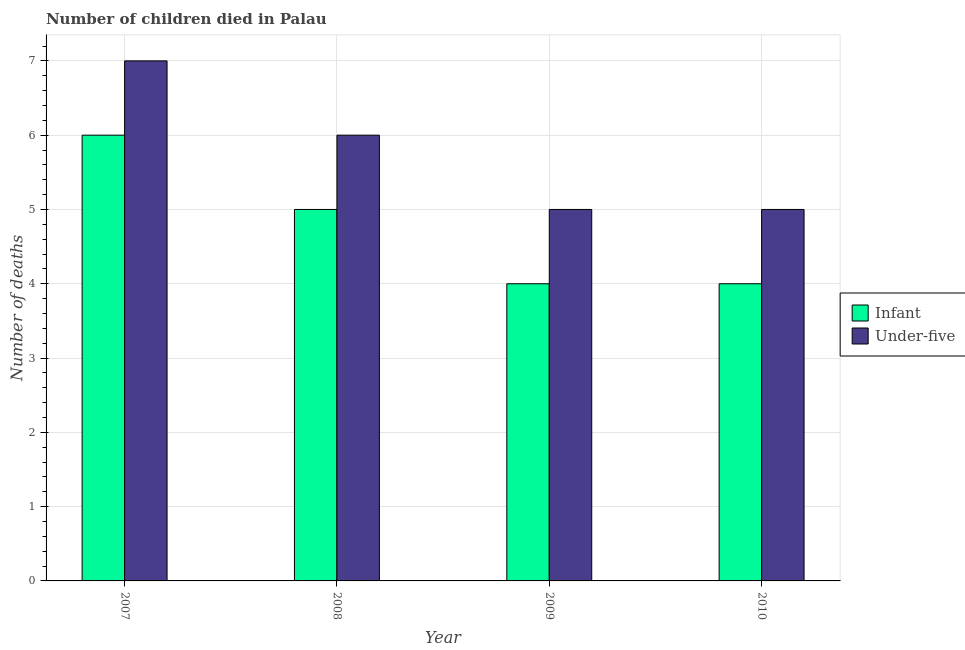How many different coloured bars are there?
Ensure brevity in your answer.  2. Are the number of bars per tick equal to the number of legend labels?
Your answer should be compact. Yes. Are the number of bars on each tick of the X-axis equal?
Ensure brevity in your answer.  Yes. How many bars are there on the 1st tick from the left?
Your answer should be very brief. 2. What is the number of under-five deaths in 2009?
Keep it short and to the point. 5. Across all years, what is the maximum number of under-five deaths?
Offer a very short reply. 7. Across all years, what is the minimum number of infant deaths?
Your answer should be compact. 4. What is the total number of infant deaths in the graph?
Offer a very short reply. 19. What is the difference between the number of infant deaths in 2007 and that in 2009?
Offer a very short reply. 2. What is the difference between the number of under-five deaths in 2009 and the number of infant deaths in 2007?
Provide a succinct answer. -2. What is the average number of under-five deaths per year?
Provide a short and direct response. 5.75. What is the ratio of the number of under-five deaths in 2008 to that in 2010?
Offer a terse response. 1.2. What is the difference between the highest and the lowest number of under-five deaths?
Your answer should be very brief. 2. Is the sum of the number of under-five deaths in 2008 and 2010 greater than the maximum number of infant deaths across all years?
Give a very brief answer. Yes. What does the 1st bar from the left in 2008 represents?
Ensure brevity in your answer.  Infant. What does the 2nd bar from the right in 2007 represents?
Give a very brief answer. Infant. How many bars are there?
Ensure brevity in your answer.  8. Are all the bars in the graph horizontal?
Offer a terse response. No. Does the graph contain grids?
Your answer should be compact. Yes. How are the legend labels stacked?
Offer a very short reply. Vertical. What is the title of the graph?
Your response must be concise. Number of children died in Palau. Does "Males" appear as one of the legend labels in the graph?
Offer a very short reply. No. What is the label or title of the X-axis?
Your answer should be compact. Year. What is the label or title of the Y-axis?
Offer a terse response. Number of deaths. What is the Number of deaths in Under-five in 2008?
Your answer should be very brief. 6. What is the Number of deaths in Infant in 2009?
Provide a short and direct response. 4. What is the Number of deaths of Under-five in 2009?
Your answer should be compact. 5. What is the Number of deaths in Infant in 2010?
Offer a terse response. 4. Across all years, what is the maximum Number of deaths in Infant?
Offer a very short reply. 6. Across all years, what is the maximum Number of deaths of Under-five?
Offer a very short reply. 7. Across all years, what is the minimum Number of deaths of Infant?
Your answer should be compact. 4. What is the total Number of deaths of Under-five in the graph?
Make the answer very short. 23. What is the difference between the Number of deaths of Infant in 2007 and that in 2008?
Your response must be concise. 1. What is the difference between the Number of deaths in Under-five in 2007 and that in 2008?
Give a very brief answer. 1. What is the difference between the Number of deaths in Under-five in 2007 and that in 2009?
Provide a short and direct response. 2. What is the difference between the Number of deaths of Infant in 2007 and that in 2010?
Your answer should be very brief. 2. What is the difference between the Number of deaths in Under-five in 2007 and that in 2010?
Provide a succinct answer. 2. What is the difference between the Number of deaths of Under-five in 2008 and that in 2009?
Ensure brevity in your answer.  1. What is the difference between the Number of deaths of Infant in 2008 and that in 2010?
Provide a short and direct response. 1. What is the difference between the Number of deaths of Under-five in 2008 and that in 2010?
Make the answer very short. 1. What is the difference between the Number of deaths in Infant in 2009 and that in 2010?
Give a very brief answer. 0. What is the difference between the Number of deaths of Under-five in 2009 and that in 2010?
Keep it short and to the point. 0. What is the difference between the Number of deaths of Infant in 2007 and the Number of deaths of Under-five in 2010?
Offer a very short reply. 1. What is the difference between the Number of deaths of Infant in 2008 and the Number of deaths of Under-five in 2010?
Provide a short and direct response. 0. What is the average Number of deaths of Infant per year?
Make the answer very short. 4.75. What is the average Number of deaths of Under-five per year?
Offer a terse response. 5.75. In the year 2008, what is the difference between the Number of deaths of Infant and Number of deaths of Under-five?
Your answer should be very brief. -1. In the year 2010, what is the difference between the Number of deaths in Infant and Number of deaths in Under-five?
Keep it short and to the point. -1. What is the ratio of the Number of deaths of Under-five in 2007 to that in 2009?
Ensure brevity in your answer.  1.4. What is the ratio of the Number of deaths in Infant in 2007 to that in 2010?
Provide a short and direct response. 1.5. What is the ratio of the Number of deaths of Under-five in 2009 to that in 2010?
Offer a terse response. 1. What is the difference between the highest and the second highest Number of deaths of Under-five?
Keep it short and to the point. 1. What is the difference between the highest and the lowest Number of deaths of Under-five?
Your answer should be compact. 2. 